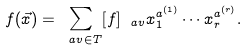Convert formula to latex. <formula><loc_0><loc_0><loc_500><loc_500>f ( \vec { x } ) = \sum _ { \ a v \in T } [ f ] _ { \ a v } x _ { 1 } ^ { a ^ { ( 1 ) } } \cdots x _ { r } ^ { a ^ { ( r ) } } .</formula> 